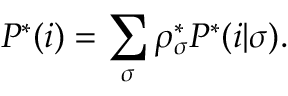<formula> <loc_0><loc_0><loc_500><loc_500>P ^ { * } ( i ) = \sum _ { \sigma } \rho _ { \sigma } ^ { * } P ^ { * } ( i | \sigma ) .</formula> 